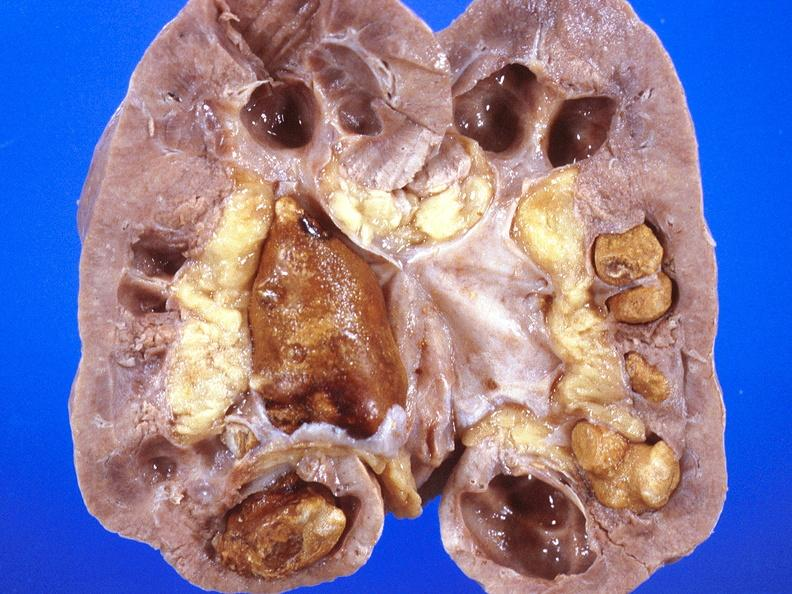where is this?
Answer the question using a single word or phrase. Urinary 